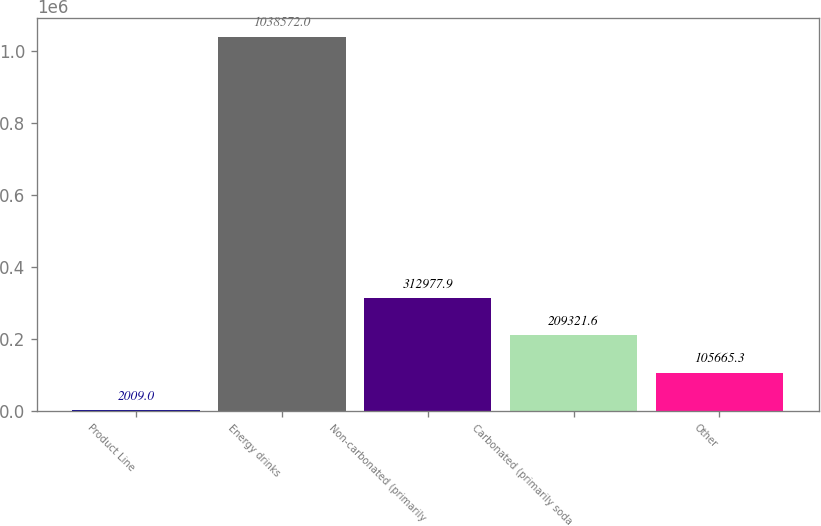Convert chart. <chart><loc_0><loc_0><loc_500><loc_500><bar_chart><fcel>Product Line<fcel>Energy drinks<fcel>Non-carbonated (primarily<fcel>Carbonated (primarily soda<fcel>Other<nl><fcel>2009<fcel>1.03857e+06<fcel>312978<fcel>209322<fcel>105665<nl></chart> 